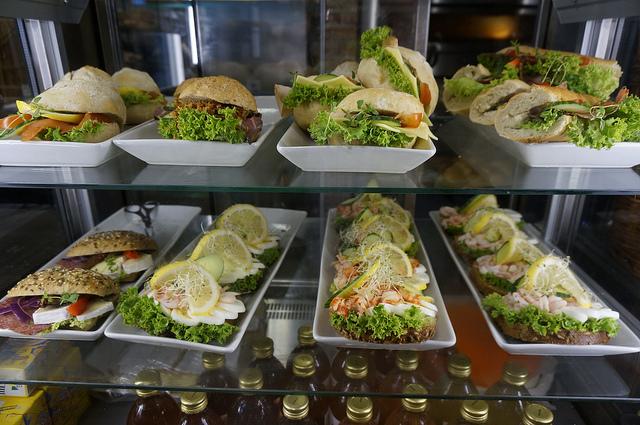Is this in a restaurant?
Concise answer only. Yes. Does this food look healthy?
Keep it brief. Yes. What is under the food trays?
Write a very short answer. Bottles. 